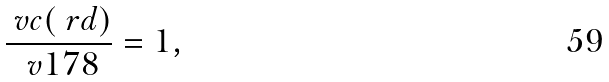<formula> <loc_0><loc_0><loc_500><loc_500>\frac { \ v c ( \ r d ) } { \ v 1 7 8 } = 1 ,</formula> 